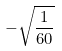<formula> <loc_0><loc_0><loc_500><loc_500>- \sqrt { \frac { 1 } { 6 0 } }</formula> 